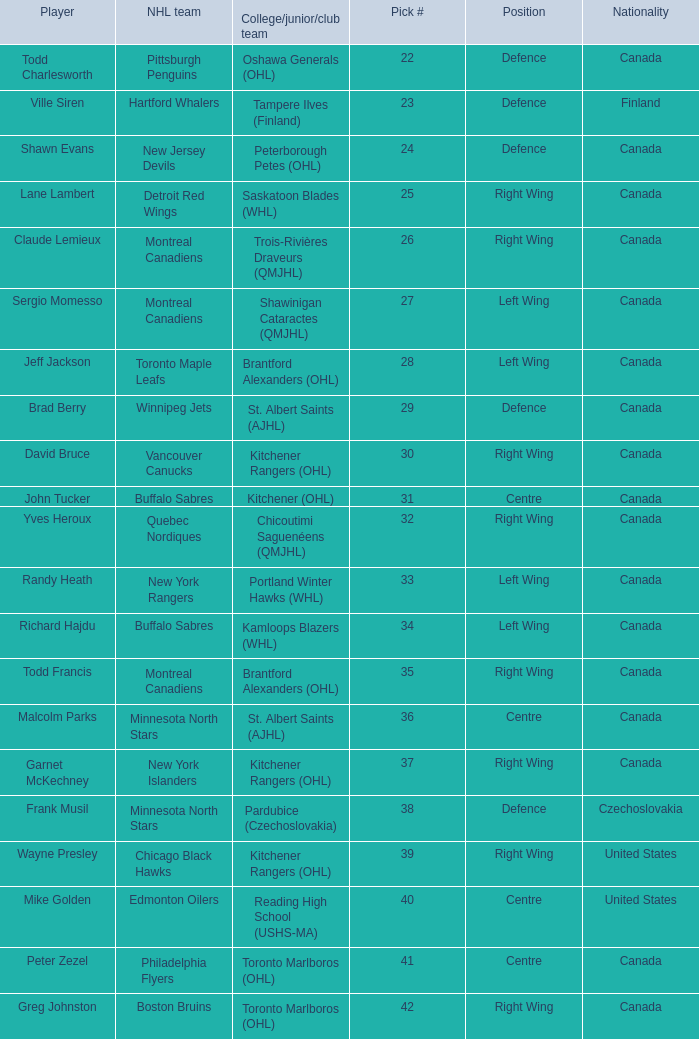What is the nationality when the player is randy heath? Canada. Would you be able to parse every entry in this table? {'header': ['Player', 'NHL team', 'College/junior/club team', 'Pick #', 'Position', 'Nationality'], 'rows': [['Todd Charlesworth', 'Pittsburgh Penguins', 'Oshawa Generals (OHL)', '22', 'Defence', 'Canada'], ['Ville Siren', 'Hartford Whalers', 'Tampere Ilves (Finland)', '23', 'Defence', 'Finland'], ['Shawn Evans', 'New Jersey Devils', 'Peterborough Petes (OHL)', '24', 'Defence', 'Canada'], ['Lane Lambert', 'Detroit Red Wings', 'Saskatoon Blades (WHL)', '25', 'Right Wing', 'Canada'], ['Claude Lemieux', 'Montreal Canadiens', 'Trois-Rivières Draveurs (QMJHL)', '26', 'Right Wing', 'Canada'], ['Sergio Momesso', 'Montreal Canadiens', 'Shawinigan Cataractes (QMJHL)', '27', 'Left Wing', 'Canada'], ['Jeff Jackson', 'Toronto Maple Leafs', 'Brantford Alexanders (OHL)', '28', 'Left Wing', 'Canada'], ['Brad Berry', 'Winnipeg Jets', 'St. Albert Saints (AJHL)', '29', 'Defence', 'Canada'], ['David Bruce', 'Vancouver Canucks', 'Kitchener Rangers (OHL)', '30', 'Right Wing', 'Canada'], ['John Tucker', 'Buffalo Sabres', 'Kitchener (OHL)', '31', 'Centre', 'Canada'], ['Yves Heroux', 'Quebec Nordiques', 'Chicoutimi Saguenéens (QMJHL)', '32', 'Right Wing', 'Canada'], ['Randy Heath', 'New York Rangers', 'Portland Winter Hawks (WHL)', '33', 'Left Wing', 'Canada'], ['Richard Hajdu', 'Buffalo Sabres', 'Kamloops Blazers (WHL)', '34', 'Left Wing', 'Canada'], ['Todd Francis', 'Montreal Canadiens', 'Brantford Alexanders (OHL)', '35', 'Right Wing', 'Canada'], ['Malcolm Parks', 'Minnesota North Stars', 'St. Albert Saints (AJHL)', '36', 'Centre', 'Canada'], ['Garnet McKechney', 'New York Islanders', 'Kitchener Rangers (OHL)', '37', 'Right Wing', 'Canada'], ['Frank Musil', 'Minnesota North Stars', 'Pardubice (Czechoslovakia)', '38', 'Defence', 'Czechoslovakia'], ['Wayne Presley', 'Chicago Black Hawks', 'Kitchener Rangers (OHL)', '39', 'Right Wing', 'United States'], ['Mike Golden', 'Edmonton Oilers', 'Reading High School (USHS-MA)', '40', 'Centre', 'United States'], ['Peter Zezel', 'Philadelphia Flyers', 'Toronto Marlboros (OHL)', '41', 'Centre', 'Canada'], ['Greg Johnston', 'Boston Bruins', 'Toronto Marlboros (OHL)', '42', 'Right Wing', 'Canada']]} 